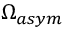<formula> <loc_0><loc_0><loc_500><loc_500>\Omega _ { a s y m }</formula> 